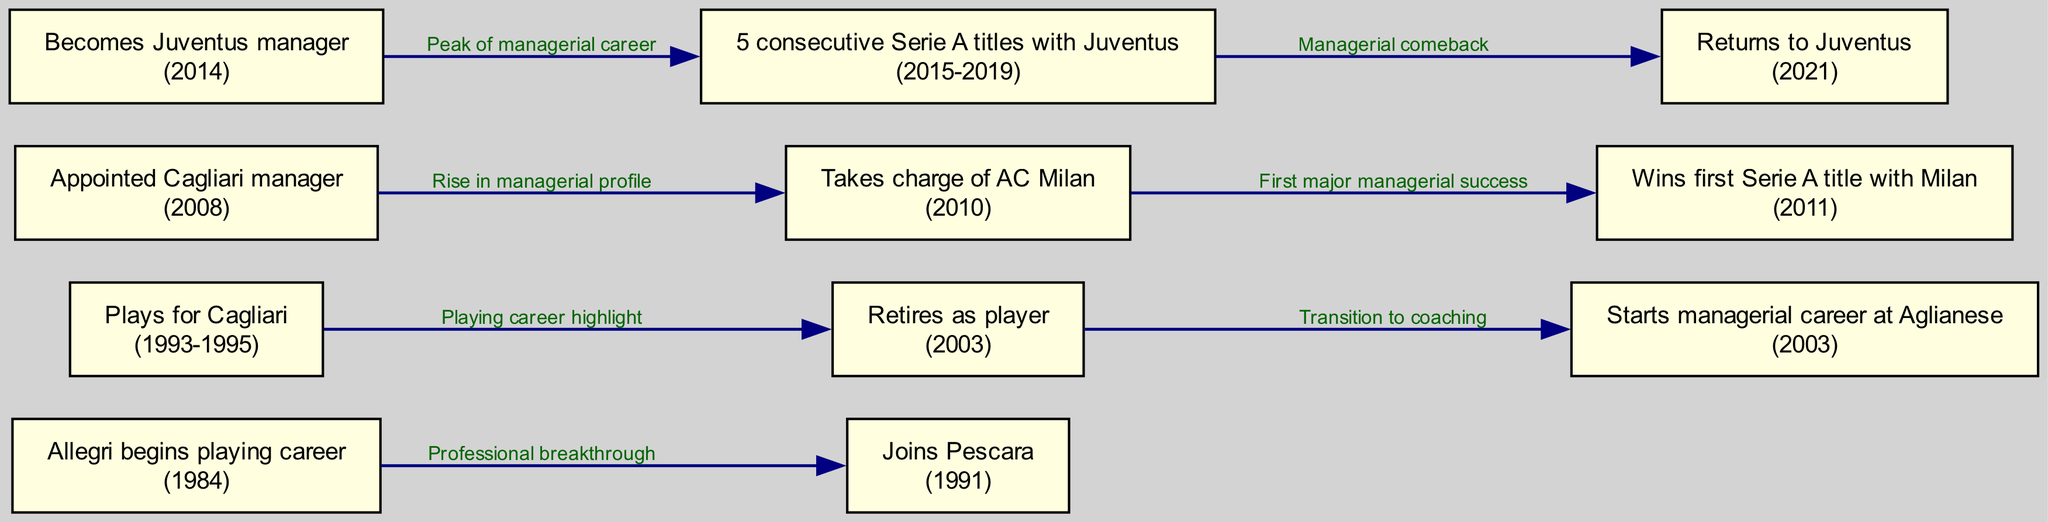What year did Allegri begin his playing career? The diagram's first node shows that Allegri began his playing career in 1984.
Answer: 1984 Which club did Allegri join in 1991? According to the second node's label, Allegri joined Pescara in 1991.
Answer: Pescara How many Serie A titles did Allegri win consecutively with Juventus? The diagram indicates that Allegri won 5 consecutive Serie A titles with Juventus, as noted in the edges connecting the relevant nodes.
Answer: 5 What significant transition did Allegri make in 2003? The edge labeled "Transition to coaching" shows that Allegri retired as a player in 2003 and started his managerial career at Aglianese in the same year.
Answer: Transition to coaching In which year did Allegri take charge of AC Milan? The edge from the node labeled "Appointed Cagliari manager" to the node for AC Milan indicates that Allegri took charge of AC Milan in 2010.
Answer: 2010 What is described as Allegri's peak of managerial career? The diagram states that the period from 2015 to 2019 represents the peak of Allegri's managerial career, with the edge pointing from his appointment at Juventus to the achievement of 5 consecutive titles.
Answer: 5 consecutive Serie A titles with Juventus What milestone does the node for winning the first Serie A title with Milan represent? The edge connecting the node "Takes charge of AC Milan" to the node "Wins first Serie A title with Milan" indicates that this was the first major success of his managerial career after taking over Milan in 2010.
Answer: First major managerial success How many nodes are related to Allegri's managerial career? By counting the nodes that mention managerial appointments or achievements, including Aglianese, Cagliari, AC Milan, and Juventus, we find that there are 5 relevant nodes related to his managerial career.
Answer: 5 What event marks Allegri's return to Juventus in the timeline? The edge labeled "Managerial comeback" indicates that Allegri's return to Juventus in 2021 is a significant event marked in the timeline.
Answer: Return to Juventus 